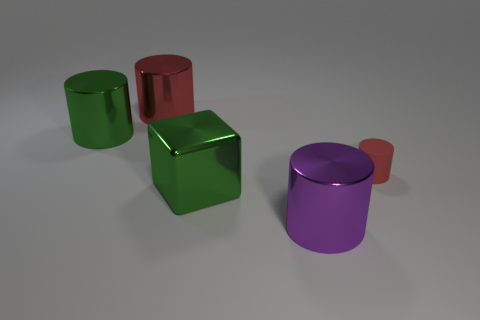Subtract all big metal cylinders. How many cylinders are left? 1 Subtract all cubes. How many objects are left? 4 Add 3 metallic objects. How many metallic objects are left? 7 Add 1 big blocks. How many big blocks exist? 2 Add 1 red cylinders. How many objects exist? 6 Subtract all purple cylinders. How many cylinders are left? 3 Subtract 0 blue blocks. How many objects are left? 5 Subtract all green cylinders. Subtract all blue spheres. How many cylinders are left? 3 Subtract all red spheres. How many yellow cylinders are left? 0 Subtract all tiny gray metal objects. Subtract all big green shiny cylinders. How many objects are left? 4 